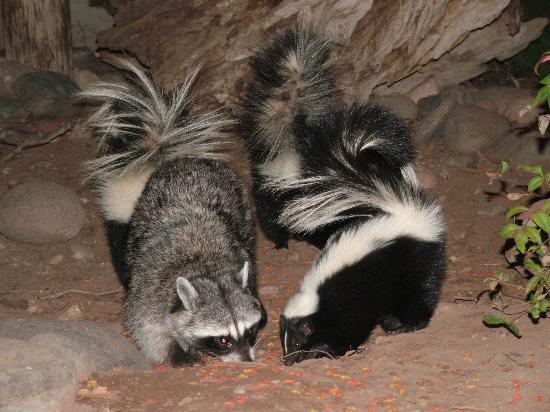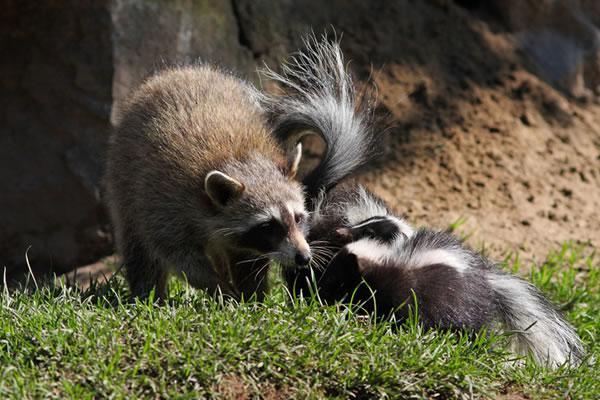The first image is the image on the left, the second image is the image on the right. Analyze the images presented: Is the assertion "There are two parallel skunks with a white vertical stripe on the front of their head." valid? Answer yes or no. No. The first image is the image on the left, the second image is the image on the right. Assess this claim about the two images: "In the left image, exactly one raccoon is standing alongside a skunk that is on all fours with its nose pointed down to a brown surface.". Correct or not? Answer yes or no. Yes. 